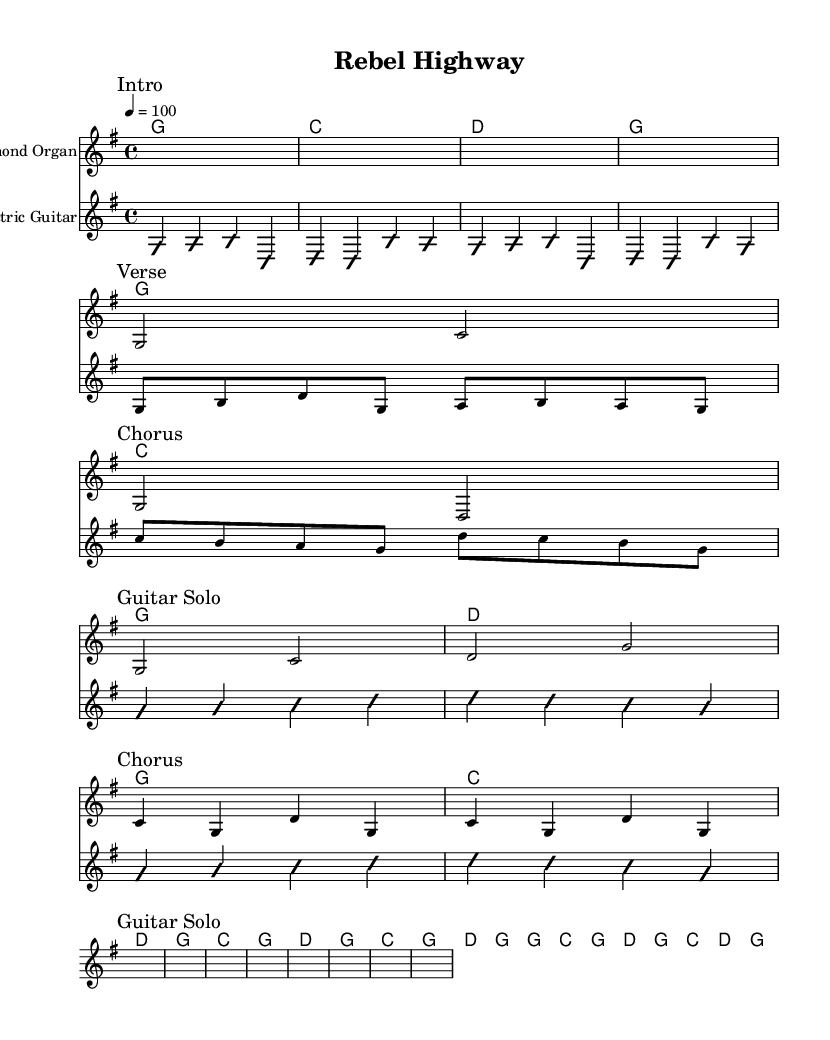What is the key signature of this music? The key signature is G major, which has one sharp (F#). This can be determined by looking at the key signature indicated at the beginning of the score.
Answer: G major What is the time signature of this piece? The time signature is 4/4, as shown at the beginning of the score, which indicates four beats in a measure, with the quarter note receiving one beat.
Answer: 4/4 What is the tempo marking for this piece? The tempo marking is quarter note equals 100, as noted in the global section of the score, which indicates the speed at which the piece should be played.
Answer: 100 How many measures are in the verse section? There are four measures in the verse section, as seen in the organ verse part where it is written and notated. Each segment contains two beats, summing up to four measures total.
Answer: Four During which section does the harmonized guitar play? The harmonized guitar plays during the chorus section, indicated in the score where the guitar chorus notation follows the organ chorus part.
Answer: Chorus What kind of musical elements are present in the guitar solo? The guitar solo features improvisation, as indicated by the "improvisationOn" and "improvisationOff" markings, suggesting that this section bends traditional melodic lines.
Answer: Improvisation How is the structure of this song typical of Country Rock? The structure includes distinct sections (verse, chorus, guitar solo) with a blend of instrumental improvisation and vocal-like melody lines typical of Country Rock traditions, which merges storytelling lyrics with Southern rock elements.
Answer: Verse, chorus, guitar solo 